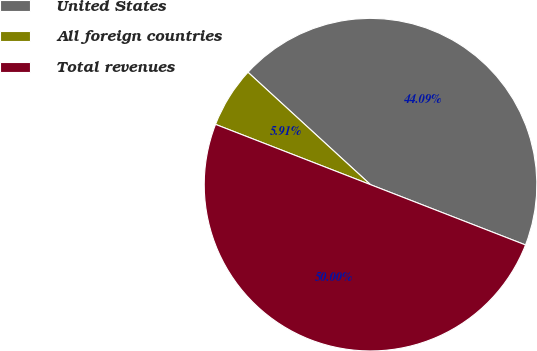Convert chart. <chart><loc_0><loc_0><loc_500><loc_500><pie_chart><fcel>United States<fcel>All foreign countries<fcel>Total revenues<nl><fcel>44.09%<fcel>5.91%<fcel>50.0%<nl></chart> 